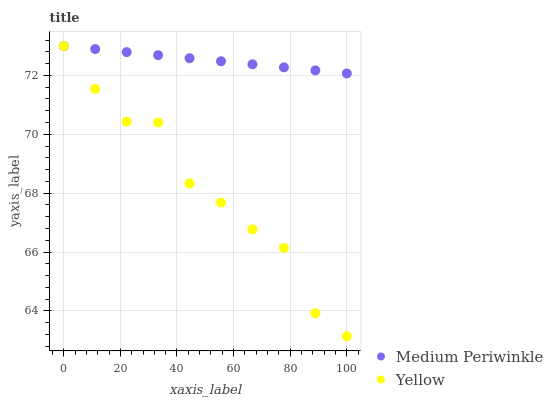Does Yellow have the minimum area under the curve?
Answer yes or no. Yes. Does Medium Periwinkle have the maximum area under the curve?
Answer yes or no. Yes. Does Yellow have the maximum area under the curve?
Answer yes or no. No. Is Medium Periwinkle the smoothest?
Answer yes or no. Yes. Is Yellow the roughest?
Answer yes or no. Yes. Is Yellow the smoothest?
Answer yes or no. No. Does Yellow have the lowest value?
Answer yes or no. Yes. Does Yellow have the highest value?
Answer yes or no. Yes. Does Yellow intersect Medium Periwinkle?
Answer yes or no. Yes. Is Yellow less than Medium Periwinkle?
Answer yes or no. No. Is Yellow greater than Medium Periwinkle?
Answer yes or no. No. 